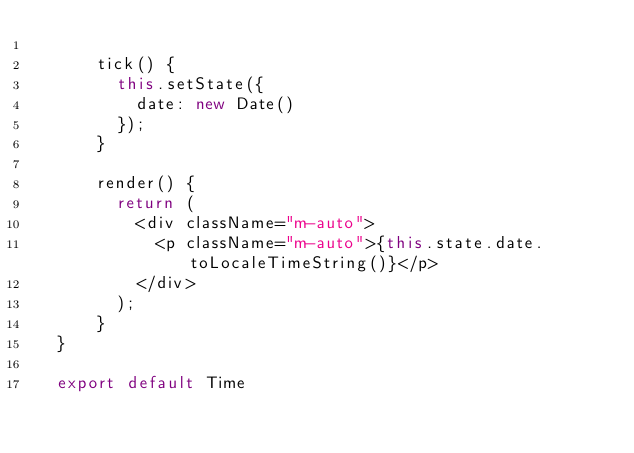Convert code to text. <code><loc_0><loc_0><loc_500><loc_500><_JavaScript_>    
      tick() {
        this.setState({
          date: new Date()
        });
      }
    
      render() {
        return (
          <div className="m-auto">
            <p className="m-auto">{this.state.date.toLocaleTimeString()}</p>
          </div>
        );
      }
  }
  
  export default Time</code> 